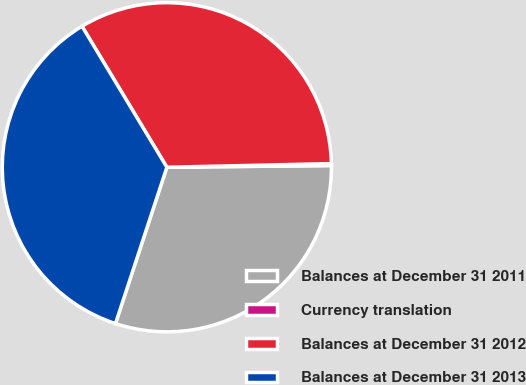<chart> <loc_0><loc_0><loc_500><loc_500><pie_chart><fcel>Balances at December 31 2011<fcel>Currency translation<fcel>Balances at December 31 2012<fcel>Balances at December 31 2013<nl><fcel>30.22%<fcel>0.19%<fcel>33.27%<fcel>36.32%<nl></chart> 